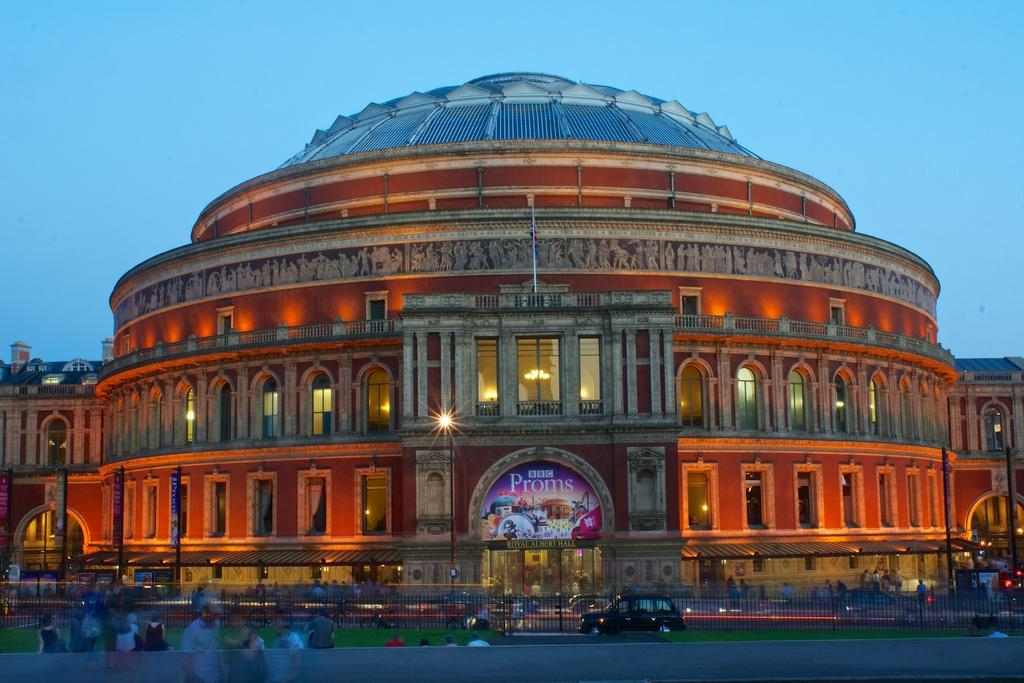What type of structure is present in the image? There is a building in the image. What are the vertical supports in the image? There are poles in the image. What are the flat, rectangular objects in the image? There are boards in the image. What are the sources of illumination in the image? There are lights in the image. What are the openings in the building in the image? There are windows in the image. What type of vegetation is present in the image? There is grass in the image. Who or what is present in the image? There are people in the image. What type of transportation is present in the image? There are vehicles in the image. What is the barrier made of in the image? There is a fence in the image. What can be seen in the background of the image? The sky is visible in the background of the image. Where is the house located in the image? There is no house mentioned in the provided facts, only a building. What type of screw is holding the lights in the image? There is no mention of screws in the provided facts; the lights are simply present in the image. What part of the brain can be seen in the image? There is no mention of a brain in the provided facts, nor is there any indication that a brain would be visible in the image. 